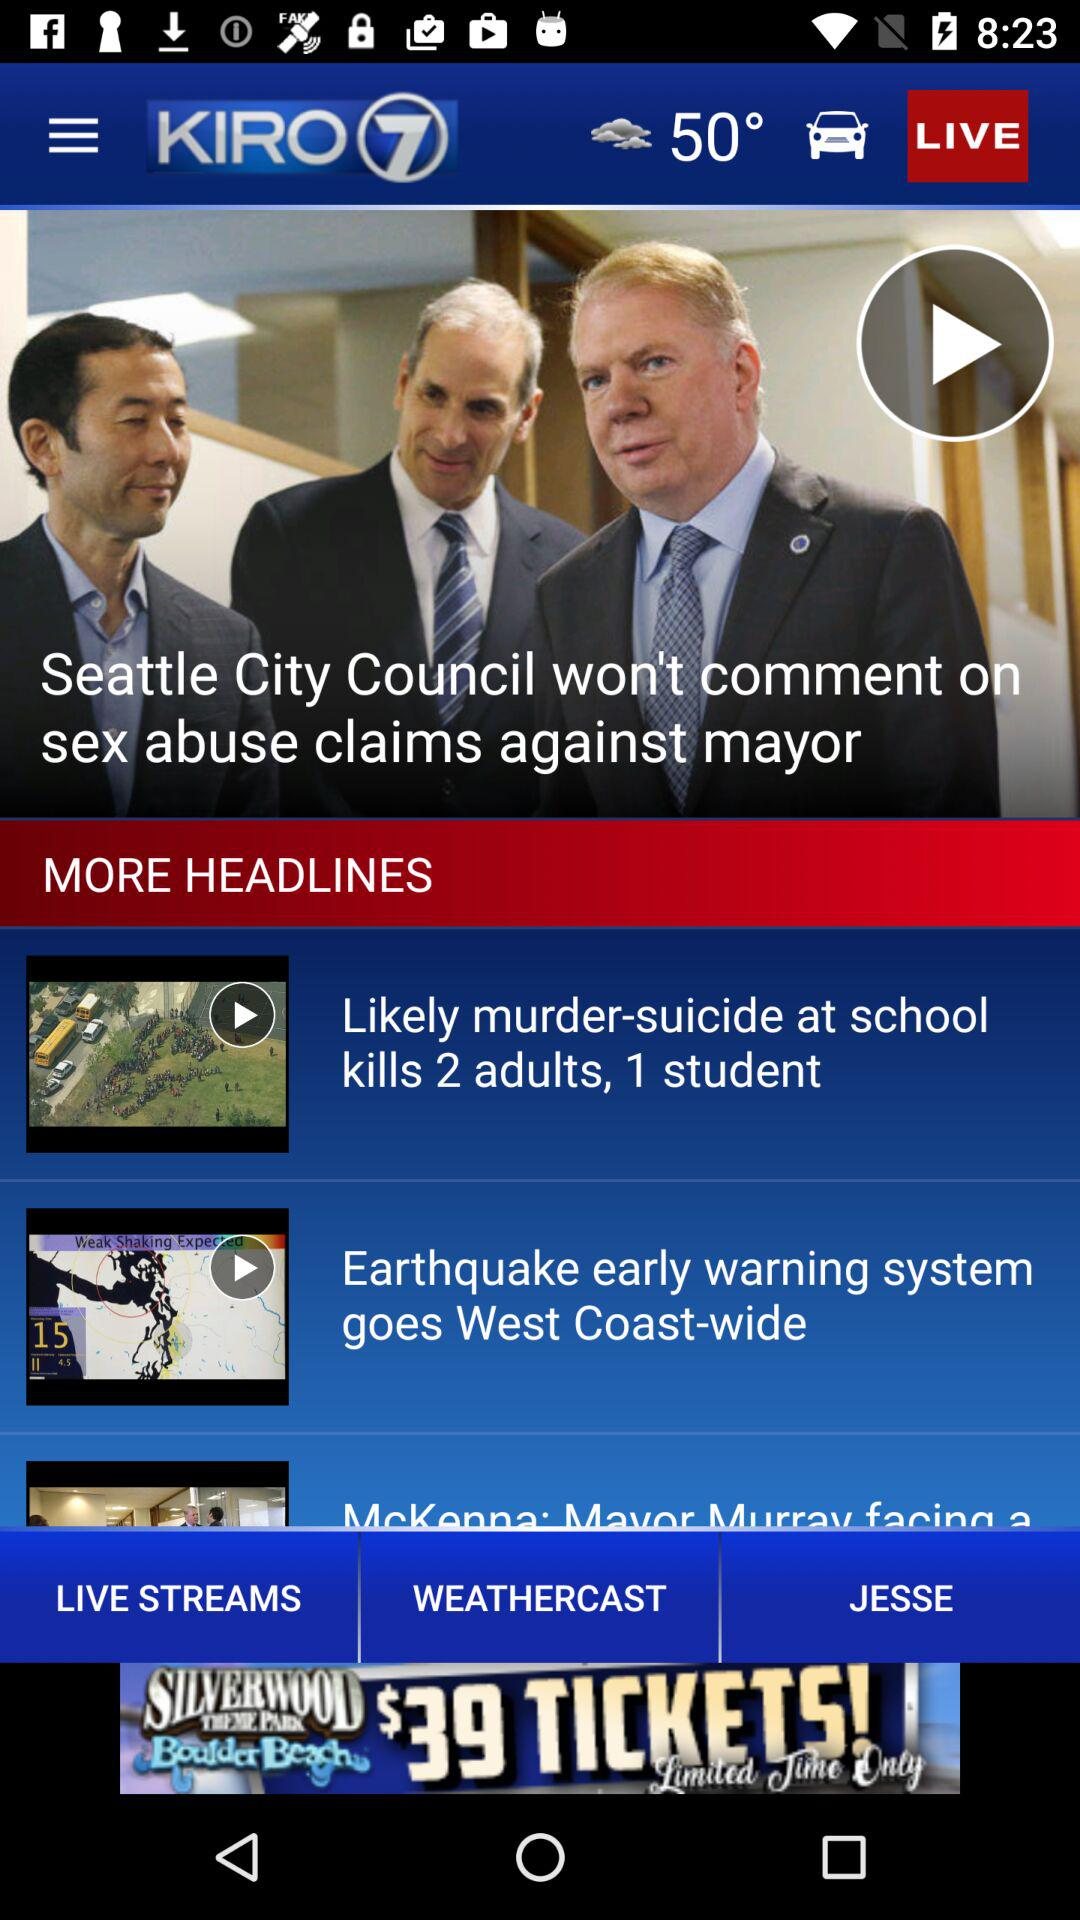What is the name of the news channel? The name of the news channel is "KIRO 7". 